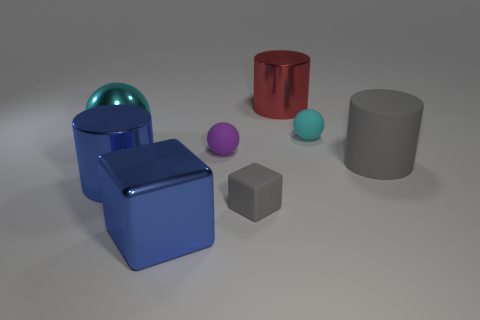Subtract all big blue metal cylinders. How many cylinders are left? 2 Add 2 blue metallic objects. How many objects exist? 10 Subtract all purple balls. How many balls are left? 2 Subtract all blocks. How many objects are left? 6 Subtract 1 cylinders. How many cylinders are left? 2 Subtract all brown cylinders. How many cyan balls are left? 2 Subtract all big metallic objects. Subtract all tiny brown metallic things. How many objects are left? 4 Add 4 large blue metallic cubes. How many large blue metallic cubes are left? 5 Add 2 small blocks. How many small blocks exist? 3 Subtract 0 red blocks. How many objects are left? 8 